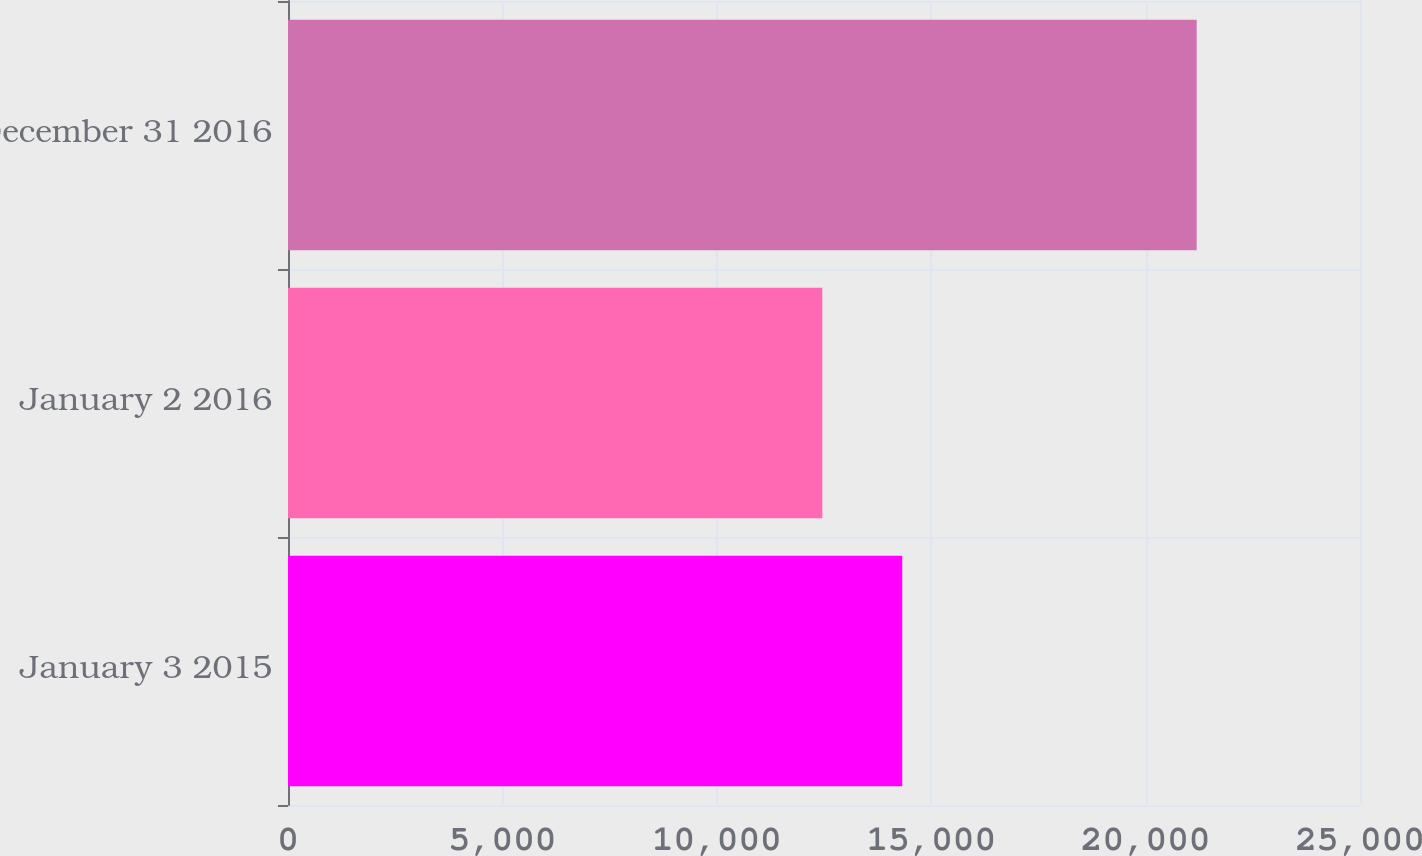Convert chart. <chart><loc_0><loc_0><loc_500><loc_500><bar_chart><fcel>January 3 2015<fcel>January 2 2016<fcel>December 31 2016<nl><fcel>14325<fcel>12461<fcel>21191<nl></chart> 